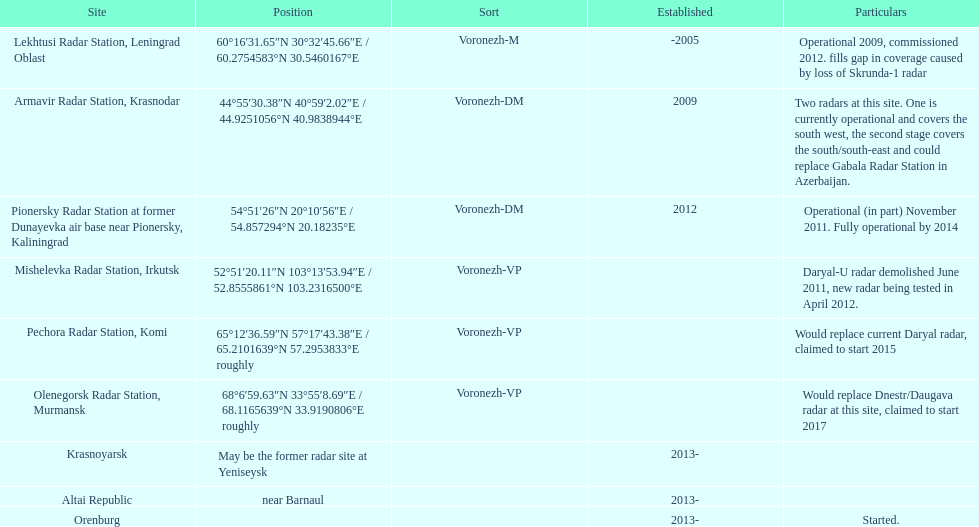Which site has the most radars? Armavir Radar Station, Krasnodar. 